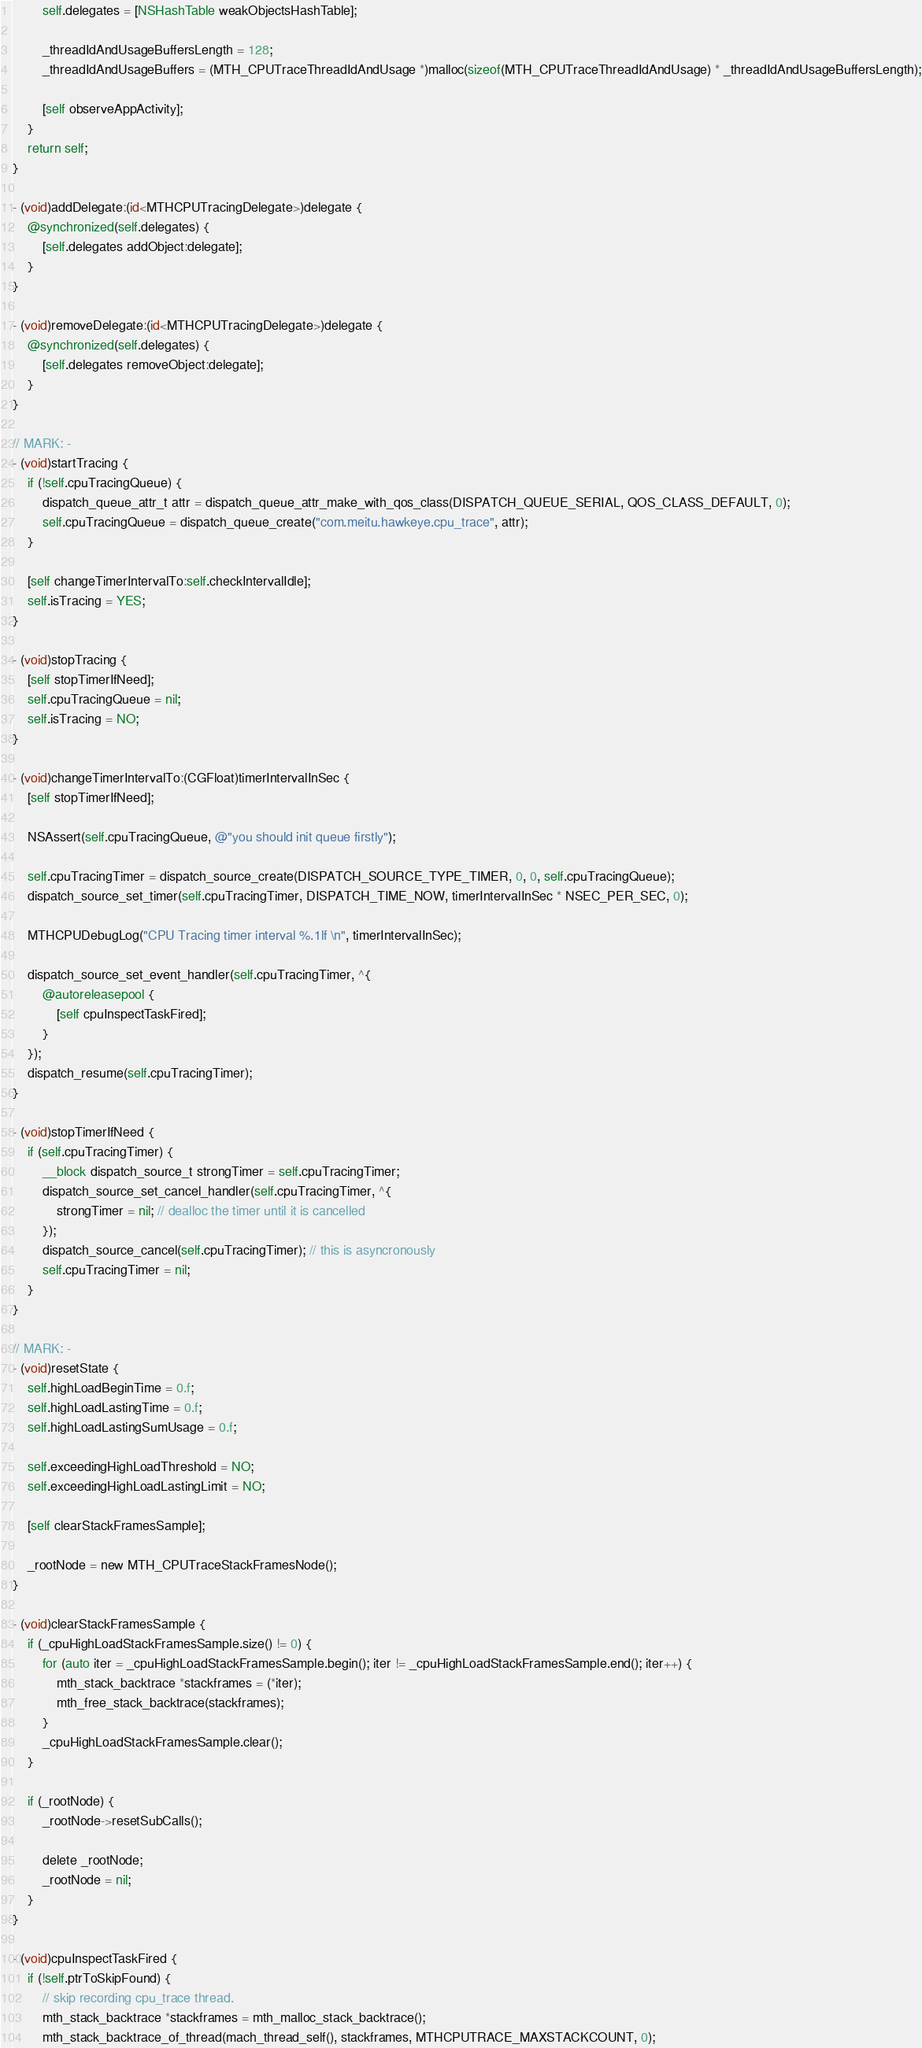<code> <loc_0><loc_0><loc_500><loc_500><_ObjectiveC_>        self.delegates = [NSHashTable weakObjectsHashTable];

        _threadIdAndUsageBuffersLength = 128;
        _threadIdAndUsageBuffers = (MTH_CPUTraceThreadIdAndUsage *)malloc(sizeof(MTH_CPUTraceThreadIdAndUsage) * _threadIdAndUsageBuffersLength);

        [self observeAppActivity];
    }
    return self;
}

- (void)addDelegate:(id<MTHCPUTracingDelegate>)delegate {
    @synchronized(self.delegates) {
        [self.delegates addObject:delegate];
    }
}

- (void)removeDelegate:(id<MTHCPUTracingDelegate>)delegate {
    @synchronized(self.delegates) {
        [self.delegates removeObject:delegate];
    }
}

// MARK: -
- (void)startTracing {
    if (!self.cpuTracingQueue) {
        dispatch_queue_attr_t attr = dispatch_queue_attr_make_with_qos_class(DISPATCH_QUEUE_SERIAL, QOS_CLASS_DEFAULT, 0);
        self.cpuTracingQueue = dispatch_queue_create("com.meitu.hawkeye.cpu_trace", attr);
    }

    [self changeTimerIntervalTo:self.checkIntervalIdle];
    self.isTracing = YES;
}

- (void)stopTracing {
    [self stopTimerIfNeed];
    self.cpuTracingQueue = nil;
    self.isTracing = NO;
}

- (void)changeTimerIntervalTo:(CGFloat)timerIntervalInSec {
    [self stopTimerIfNeed];

    NSAssert(self.cpuTracingQueue, @"you should init queue firstly");

    self.cpuTracingTimer = dispatch_source_create(DISPATCH_SOURCE_TYPE_TIMER, 0, 0, self.cpuTracingQueue);
    dispatch_source_set_timer(self.cpuTracingTimer, DISPATCH_TIME_NOW, timerIntervalInSec * NSEC_PER_SEC, 0);

    MTHCPUDebugLog("CPU Tracing timer interval %.1lf \n", timerIntervalInSec);

    dispatch_source_set_event_handler(self.cpuTracingTimer, ^{
        @autoreleasepool {
            [self cpuInspectTaskFired];
        }
    });
    dispatch_resume(self.cpuTracingTimer);
}

- (void)stopTimerIfNeed {
    if (self.cpuTracingTimer) {
        __block dispatch_source_t strongTimer = self.cpuTracingTimer;
        dispatch_source_set_cancel_handler(self.cpuTracingTimer, ^{
            strongTimer = nil; // dealloc the timer until it is cancelled
        });
        dispatch_source_cancel(self.cpuTracingTimer); // this is asyncronously
        self.cpuTracingTimer = nil;
    }
}

// MARK: -
- (void)resetState {
    self.highLoadBeginTime = 0.f;
    self.highLoadLastingTime = 0.f;
    self.highLoadLastingSumUsage = 0.f;

    self.exceedingHighLoadThreshold = NO;
    self.exceedingHighLoadLastingLimit = NO;

    [self clearStackFramesSample];

    _rootNode = new MTH_CPUTraceStackFramesNode();
}

- (void)clearStackFramesSample {
    if (_cpuHighLoadStackFramesSample.size() != 0) {
        for (auto iter = _cpuHighLoadStackFramesSample.begin(); iter != _cpuHighLoadStackFramesSample.end(); iter++) {
            mth_stack_backtrace *stackframes = (*iter);
            mth_free_stack_backtrace(stackframes);
        }
        _cpuHighLoadStackFramesSample.clear();
    }

    if (_rootNode) {
        _rootNode->resetSubCalls();

        delete _rootNode;
        _rootNode = nil;
    }
}

- (void)cpuInspectTaskFired {
    if (!self.ptrToSkipFound) {
        // skip recording cpu_trace thread.
        mth_stack_backtrace *stackframes = mth_malloc_stack_backtrace();
        mth_stack_backtrace_of_thread(mach_thread_self(), stackframes, MTHCPUTRACE_MAXSTACKCOUNT, 0);</code> 